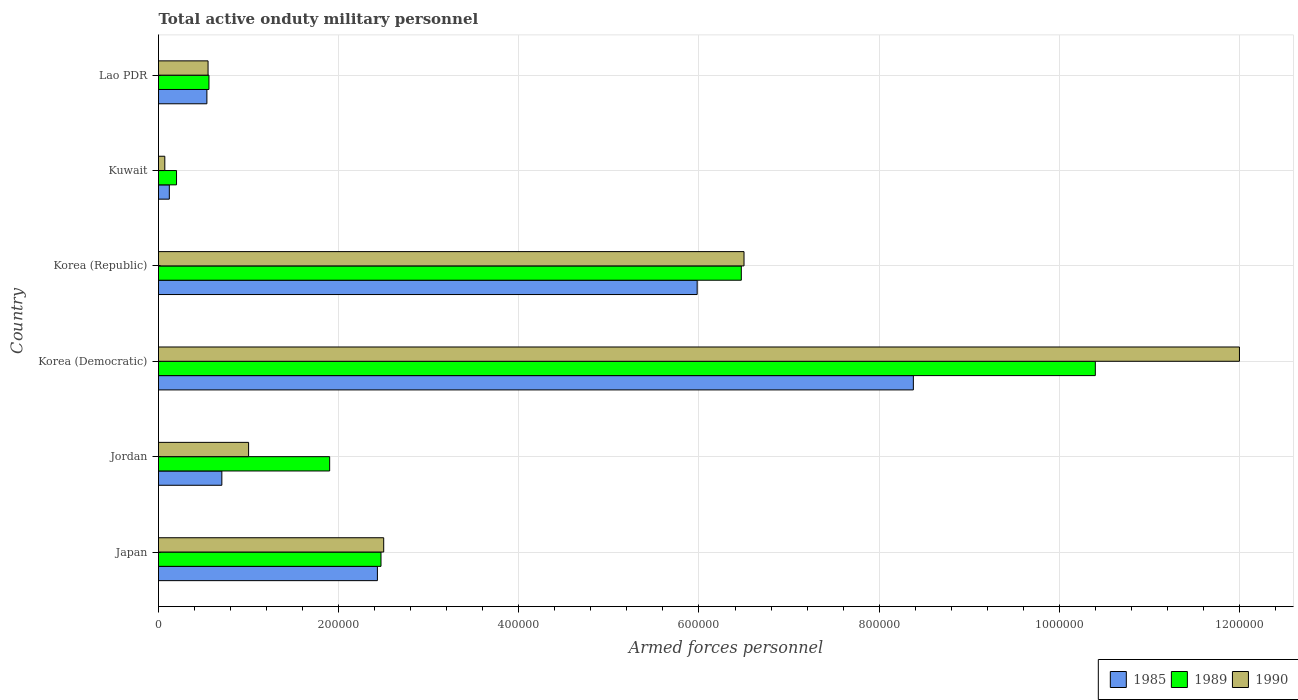How many groups of bars are there?
Offer a terse response. 6. Are the number of bars on each tick of the Y-axis equal?
Ensure brevity in your answer.  Yes. What is the label of the 3rd group of bars from the top?
Your response must be concise. Korea (Republic). In how many cases, is the number of bars for a given country not equal to the number of legend labels?
Give a very brief answer. 0. What is the number of armed forces personnel in 1990 in Korea (Republic)?
Offer a terse response. 6.50e+05. Across all countries, what is the maximum number of armed forces personnel in 1990?
Provide a short and direct response. 1.20e+06. Across all countries, what is the minimum number of armed forces personnel in 1990?
Ensure brevity in your answer.  7000. In which country was the number of armed forces personnel in 1989 maximum?
Ensure brevity in your answer.  Korea (Democratic). In which country was the number of armed forces personnel in 1989 minimum?
Keep it short and to the point. Kuwait. What is the total number of armed forces personnel in 1990 in the graph?
Provide a short and direct response. 2.26e+06. What is the difference between the number of armed forces personnel in 1985 in Korea (Democratic) and that in Kuwait?
Keep it short and to the point. 8.26e+05. What is the average number of armed forces personnel in 1990 per country?
Your answer should be compact. 3.77e+05. What is the difference between the number of armed forces personnel in 1989 and number of armed forces personnel in 1985 in Korea (Republic)?
Keep it short and to the point. 4.90e+04. What is the ratio of the number of armed forces personnel in 1989 in Japan to that in Korea (Democratic)?
Provide a short and direct response. 0.24. Is the difference between the number of armed forces personnel in 1989 in Korea (Republic) and Lao PDR greater than the difference between the number of armed forces personnel in 1985 in Korea (Republic) and Lao PDR?
Offer a very short reply. Yes. What is the difference between the highest and the second highest number of armed forces personnel in 1990?
Offer a terse response. 5.50e+05. What is the difference between the highest and the lowest number of armed forces personnel in 1989?
Provide a short and direct response. 1.02e+06. In how many countries, is the number of armed forces personnel in 1989 greater than the average number of armed forces personnel in 1989 taken over all countries?
Provide a succinct answer. 2. What does the 2nd bar from the bottom in Jordan represents?
Your answer should be compact. 1989. Is it the case that in every country, the sum of the number of armed forces personnel in 1989 and number of armed forces personnel in 1985 is greater than the number of armed forces personnel in 1990?
Your answer should be compact. Yes. Are all the bars in the graph horizontal?
Ensure brevity in your answer.  Yes. How many countries are there in the graph?
Keep it short and to the point. 6. Are the values on the major ticks of X-axis written in scientific E-notation?
Offer a terse response. No. Does the graph contain grids?
Keep it short and to the point. Yes. How are the legend labels stacked?
Offer a very short reply. Horizontal. What is the title of the graph?
Your answer should be compact. Total active onduty military personnel. Does "1969" appear as one of the legend labels in the graph?
Your response must be concise. No. What is the label or title of the X-axis?
Your response must be concise. Armed forces personnel. What is the Armed forces personnel in 1985 in Japan?
Your answer should be very brief. 2.43e+05. What is the Armed forces personnel of 1989 in Japan?
Offer a terse response. 2.47e+05. What is the Armed forces personnel of 1985 in Jordan?
Offer a very short reply. 7.03e+04. What is the Armed forces personnel of 1989 in Jordan?
Give a very brief answer. 1.90e+05. What is the Armed forces personnel of 1990 in Jordan?
Offer a terse response. 1.00e+05. What is the Armed forces personnel in 1985 in Korea (Democratic)?
Keep it short and to the point. 8.38e+05. What is the Armed forces personnel of 1989 in Korea (Democratic)?
Give a very brief answer. 1.04e+06. What is the Armed forces personnel in 1990 in Korea (Democratic)?
Provide a short and direct response. 1.20e+06. What is the Armed forces personnel in 1985 in Korea (Republic)?
Make the answer very short. 5.98e+05. What is the Armed forces personnel in 1989 in Korea (Republic)?
Provide a succinct answer. 6.47e+05. What is the Armed forces personnel of 1990 in Korea (Republic)?
Your answer should be compact. 6.50e+05. What is the Armed forces personnel of 1985 in Kuwait?
Ensure brevity in your answer.  1.20e+04. What is the Armed forces personnel in 1990 in Kuwait?
Provide a short and direct response. 7000. What is the Armed forces personnel in 1985 in Lao PDR?
Offer a terse response. 5.37e+04. What is the Armed forces personnel of 1989 in Lao PDR?
Make the answer very short. 5.60e+04. What is the Armed forces personnel of 1990 in Lao PDR?
Make the answer very short. 5.50e+04. Across all countries, what is the maximum Armed forces personnel of 1985?
Your answer should be very brief. 8.38e+05. Across all countries, what is the maximum Armed forces personnel of 1989?
Offer a terse response. 1.04e+06. Across all countries, what is the maximum Armed forces personnel in 1990?
Offer a very short reply. 1.20e+06. Across all countries, what is the minimum Armed forces personnel of 1985?
Offer a very short reply. 1.20e+04. Across all countries, what is the minimum Armed forces personnel in 1989?
Your response must be concise. 2.00e+04. Across all countries, what is the minimum Armed forces personnel of 1990?
Your answer should be compact. 7000. What is the total Armed forces personnel in 1985 in the graph?
Provide a succinct answer. 1.82e+06. What is the total Armed forces personnel in 1989 in the graph?
Your response must be concise. 2.20e+06. What is the total Armed forces personnel in 1990 in the graph?
Make the answer very short. 2.26e+06. What is the difference between the Armed forces personnel of 1985 in Japan and that in Jordan?
Ensure brevity in your answer.  1.73e+05. What is the difference between the Armed forces personnel in 1989 in Japan and that in Jordan?
Keep it short and to the point. 5.70e+04. What is the difference between the Armed forces personnel in 1985 in Japan and that in Korea (Democratic)?
Your answer should be compact. -5.95e+05. What is the difference between the Armed forces personnel of 1989 in Japan and that in Korea (Democratic)?
Provide a succinct answer. -7.93e+05. What is the difference between the Armed forces personnel in 1990 in Japan and that in Korea (Democratic)?
Keep it short and to the point. -9.50e+05. What is the difference between the Armed forces personnel of 1985 in Japan and that in Korea (Republic)?
Provide a succinct answer. -3.55e+05. What is the difference between the Armed forces personnel in 1989 in Japan and that in Korea (Republic)?
Provide a short and direct response. -4.00e+05. What is the difference between the Armed forces personnel in 1990 in Japan and that in Korea (Republic)?
Provide a succinct answer. -4.00e+05. What is the difference between the Armed forces personnel in 1985 in Japan and that in Kuwait?
Keep it short and to the point. 2.31e+05. What is the difference between the Armed forces personnel of 1989 in Japan and that in Kuwait?
Your answer should be compact. 2.27e+05. What is the difference between the Armed forces personnel of 1990 in Japan and that in Kuwait?
Your answer should be compact. 2.43e+05. What is the difference between the Armed forces personnel in 1985 in Japan and that in Lao PDR?
Your answer should be very brief. 1.89e+05. What is the difference between the Armed forces personnel in 1989 in Japan and that in Lao PDR?
Offer a very short reply. 1.91e+05. What is the difference between the Armed forces personnel in 1990 in Japan and that in Lao PDR?
Your response must be concise. 1.95e+05. What is the difference between the Armed forces personnel in 1985 in Jordan and that in Korea (Democratic)?
Give a very brief answer. -7.68e+05. What is the difference between the Armed forces personnel of 1989 in Jordan and that in Korea (Democratic)?
Provide a succinct answer. -8.50e+05. What is the difference between the Armed forces personnel of 1990 in Jordan and that in Korea (Democratic)?
Offer a terse response. -1.10e+06. What is the difference between the Armed forces personnel of 1985 in Jordan and that in Korea (Republic)?
Offer a terse response. -5.28e+05. What is the difference between the Armed forces personnel of 1989 in Jordan and that in Korea (Republic)?
Your answer should be very brief. -4.57e+05. What is the difference between the Armed forces personnel of 1990 in Jordan and that in Korea (Republic)?
Make the answer very short. -5.50e+05. What is the difference between the Armed forces personnel in 1985 in Jordan and that in Kuwait?
Provide a succinct answer. 5.83e+04. What is the difference between the Armed forces personnel of 1989 in Jordan and that in Kuwait?
Keep it short and to the point. 1.70e+05. What is the difference between the Armed forces personnel in 1990 in Jordan and that in Kuwait?
Your answer should be compact. 9.30e+04. What is the difference between the Armed forces personnel of 1985 in Jordan and that in Lao PDR?
Give a very brief answer. 1.66e+04. What is the difference between the Armed forces personnel of 1989 in Jordan and that in Lao PDR?
Offer a terse response. 1.34e+05. What is the difference between the Armed forces personnel in 1990 in Jordan and that in Lao PDR?
Offer a very short reply. 4.50e+04. What is the difference between the Armed forces personnel in 1989 in Korea (Democratic) and that in Korea (Republic)?
Your answer should be very brief. 3.93e+05. What is the difference between the Armed forces personnel in 1990 in Korea (Democratic) and that in Korea (Republic)?
Offer a very short reply. 5.50e+05. What is the difference between the Armed forces personnel of 1985 in Korea (Democratic) and that in Kuwait?
Your answer should be compact. 8.26e+05. What is the difference between the Armed forces personnel of 1989 in Korea (Democratic) and that in Kuwait?
Give a very brief answer. 1.02e+06. What is the difference between the Armed forces personnel in 1990 in Korea (Democratic) and that in Kuwait?
Keep it short and to the point. 1.19e+06. What is the difference between the Armed forces personnel of 1985 in Korea (Democratic) and that in Lao PDR?
Your answer should be compact. 7.84e+05. What is the difference between the Armed forces personnel in 1989 in Korea (Democratic) and that in Lao PDR?
Ensure brevity in your answer.  9.84e+05. What is the difference between the Armed forces personnel in 1990 in Korea (Democratic) and that in Lao PDR?
Provide a short and direct response. 1.14e+06. What is the difference between the Armed forces personnel of 1985 in Korea (Republic) and that in Kuwait?
Give a very brief answer. 5.86e+05. What is the difference between the Armed forces personnel in 1989 in Korea (Republic) and that in Kuwait?
Ensure brevity in your answer.  6.27e+05. What is the difference between the Armed forces personnel in 1990 in Korea (Republic) and that in Kuwait?
Keep it short and to the point. 6.43e+05. What is the difference between the Armed forces personnel in 1985 in Korea (Republic) and that in Lao PDR?
Provide a succinct answer. 5.44e+05. What is the difference between the Armed forces personnel in 1989 in Korea (Republic) and that in Lao PDR?
Your answer should be very brief. 5.91e+05. What is the difference between the Armed forces personnel of 1990 in Korea (Republic) and that in Lao PDR?
Offer a terse response. 5.95e+05. What is the difference between the Armed forces personnel of 1985 in Kuwait and that in Lao PDR?
Ensure brevity in your answer.  -4.17e+04. What is the difference between the Armed forces personnel in 1989 in Kuwait and that in Lao PDR?
Make the answer very short. -3.60e+04. What is the difference between the Armed forces personnel in 1990 in Kuwait and that in Lao PDR?
Your response must be concise. -4.80e+04. What is the difference between the Armed forces personnel in 1985 in Japan and the Armed forces personnel in 1989 in Jordan?
Provide a short and direct response. 5.30e+04. What is the difference between the Armed forces personnel of 1985 in Japan and the Armed forces personnel of 1990 in Jordan?
Keep it short and to the point. 1.43e+05. What is the difference between the Armed forces personnel of 1989 in Japan and the Armed forces personnel of 1990 in Jordan?
Provide a succinct answer. 1.47e+05. What is the difference between the Armed forces personnel of 1985 in Japan and the Armed forces personnel of 1989 in Korea (Democratic)?
Provide a short and direct response. -7.97e+05. What is the difference between the Armed forces personnel in 1985 in Japan and the Armed forces personnel in 1990 in Korea (Democratic)?
Provide a succinct answer. -9.57e+05. What is the difference between the Armed forces personnel of 1989 in Japan and the Armed forces personnel of 1990 in Korea (Democratic)?
Provide a short and direct response. -9.53e+05. What is the difference between the Armed forces personnel of 1985 in Japan and the Armed forces personnel of 1989 in Korea (Republic)?
Your answer should be compact. -4.04e+05. What is the difference between the Armed forces personnel of 1985 in Japan and the Armed forces personnel of 1990 in Korea (Republic)?
Your answer should be very brief. -4.07e+05. What is the difference between the Armed forces personnel in 1989 in Japan and the Armed forces personnel in 1990 in Korea (Republic)?
Provide a succinct answer. -4.03e+05. What is the difference between the Armed forces personnel in 1985 in Japan and the Armed forces personnel in 1989 in Kuwait?
Keep it short and to the point. 2.23e+05. What is the difference between the Armed forces personnel of 1985 in Japan and the Armed forces personnel of 1990 in Kuwait?
Offer a very short reply. 2.36e+05. What is the difference between the Armed forces personnel in 1989 in Japan and the Armed forces personnel in 1990 in Kuwait?
Make the answer very short. 2.40e+05. What is the difference between the Armed forces personnel in 1985 in Japan and the Armed forces personnel in 1989 in Lao PDR?
Your answer should be compact. 1.87e+05. What is the difference between the Armed forces personnel of 1985 in Japan and the Armed forces personnel of 1990 in Lao PDR?
Give a very brief answer. 1.88e+05. What is the difference between the Armed forces personnel in 1989 in Japan and the Armed forces personnel in 1990 in Lao PDR?
Keep it short and to the point. 1.92e+05. What is the difference between the Armed forces personnel in 1985 in Jordan and the Armed forces personnel in 1989 in Korea (Democratic)?
Give a very brief answer. -9.70e+05. What is the difference between the Armed forces personnel in 1985 in Jordan and the Armed forces personnel in 1990 in Korea (Democratic)?
Offer a terse response. -1.13e+06. What is the difference between the Armed forces personnel in 1989 in Jordan and the Armed forces personnel in 1990 in Korea (Democratic)?
Make the answer very short. -1.01e+06. What is the difference between the Armed forces personnel in 1985 in Jordan and the Armed forces personnel in 1989 in Korea (Republic)?
Provide a short and direct response. -5.77e+05. What is the difference between the Armed forces personnel of 1985 in Jordan and the Armed forces personnel of 1990 in Korea (Republic)?
Make the answer very short. -5.80e+05. What is the difference between the Armed forces personnel in 1989 in Jordan and the Armed forces personnel in 1990 in Korea (Republic)?
Your answer should be very brief. -4.60e+05. What is the difference between the Armed forces personnel in 1985 in Jordan and the Armed forces personnel in 1989 in Kuwait?
Keep it short and to the point. 5.03e+04. What is the difference between the Armed forces personnel of 1985 in Jordan and the Armed forces personnel of 1990 in Kuwait?
Your answer should be compact. 6.33e+04. What is the difference between the Armed forces personnel in 1989 in Jordan and the Armed forces personnel in 1990 in Kuwait?
Provide a short and direct response. 1.83e+05. What is the difference between the Armed forces personnel of 1985 in Jordan and the Armed forces personnel of 1989 in Lao PDR?
Your answer should be very brief. 1.43e+04. What is the difference between the Armed forces personnel of 1985 in Jordan and the Armed forces personnel of 1990 in Lao PDR?
Offer a terse response. 1.53e+04. What is the difference between the Armed forces personnel of 1989 in Jordan and the Armed forces personnel of 1990 in Lao PDR?
Offer a terse response. 1.35e+05. What is the difference between the Armed forces personnel in 1985 in Korea (Democratic) and the Armed forces personnel in 1989 in Korea (Republic)?
Offer a terse response. 1.91e+05. What is the difference between the Armed forces personnel of 1985 in Korea (Democratic) and the Armed forces personnel of 1990 in Korea (Republic)?
Keep it short and to the point. 1.88e+05. What is the difference between the Armed forces personnel of 1989 in Korea (Democratic) and the Armed forces personnel of 1990 in Korea (Republic)?
Your answer should be compact. 3.90e+05. What is the difference between the Armed forces personnel of 1985 in Korea (Democratic) and the Armed forces personnel of 1989 in Kuwait?
Provide a succinct answer. 8.18e+05. What is the difference between the Armed forces personnel of 1985 in Korea (Democratic) and the Armed forces personnel of 1990 in Kuwait?
Your answer should be very brief. 8.31e+05. What is the difference between the Armed forces personnel of 1989 in Korea (Democratic) and the Armed forces personnel of 1990 in Kuwait?
Provide a succinct answer. 1.03e+06. What is the difference between the Armed forces personnel in 1985 in Korea (Democratic) and the Armed forces personnel in 1989 in Lao PDR?
Your answer should be very brief. 7.82e+05. What is the difference between the Armed forces personnel of 1985 in Korea (Democratic) and the Armed forces personnel of 1990 in Lao PDR?
Keep it short and to the point. 7.83e+05. What is the difference between the Armed forces personnel in 1989 in Korea (Democratic) and the Armed forces personnel in 1990 in Lao PDR?
Make the answer very short. 9.85e+05. What is the difference between the Armed forces personnel in 1985 in Korea (Republic) and the Armed forces personnel in 1989 in Kuwait?
Your answer should be compact. 5.78e+05. What is the difference between the Armed forces personnel in 1985 in Korea (Republic) and the Armed forces personnel in 1990 in Kuwait?
Ensure brevity in your answer.  5.91e+05. What is the difference between the Armed forces personnel of 1989 in Korea (Republic) and the Armed forces personnel of 1990 in Kuwait?
Provide a succinct answer. 6.40e+05. What is the difference between the Armed forces personnel in 1985 in Korea (Republic) and the Armed forces personnel in 1989 in Lao PDR?
Give a very brief answer. 5.42e+05. What is the difference between the Armed forces personnel in 1985 in Korea (Republic) and the Armed forces personnel in 1990 in Lao PDR?
Your response must be concise. 5.43e+05. What is the difference between the Armed forces personnel of 1989 in Korea (Republic) and the Armed forces personnel of 1990 in Lao PDR?
Offer a terse response. 5.92e+05. What is the difference between the Armed forces personnel in 1985 in Kuwait and the Armed forces personnel in 1989 in Lao PDR?
Ensure brevity in your answer.  -4.40e+04. What is the difference between the Armed forces personnel of 1985 in Kuwait and the Armed forces personnel of 1990 in Lao PDR?
Make the answer very short. -4.30e+04. What is the difference between the Armed forces personnel in 1989 in Kuwait and the Armed forces personnel in 1990 in Lao PDR?
Make the answer very short. -3.50e+04. What is the average Armed forces personnel of 1985 per country?
Your answer should be very brief. 3.02e+05. What is the average Armed forces personnel in 1989 per country?
Offer a terse response. 3.67e+05. What is the average Armed forces personnel of 1990 per country?
Offer a very short reply. 3.77e+05. What is the difference between the Armed forces personnel of 1985 and Armed forces personnel of 1989 in Japan?
Offer a very short reply. -4000. What is the difference between the Armed forces personnel in 1985 and Armed forces personnel in 1990 in Japan?
Keep it short and to the point. -7000. What is the difference between the Armed forces personnel of 1989 and Armed forces personnel of 1990 in Japan?
Provide a succinct answer. -3000. What is the difference between the Armed forces personnel of 1985 and Armed forces personnel of 1989 in Jordan?
Give a very brief answer. -1.20e+05. What is the difference between the Armed forces personnel in 1985 and Armed forces personnel in 1990 in Jordan?
Provide a short and direct response. -2.97e+04. What is the difference between the Armed forces personnel in 1985 and Armed forces personnel in 1989 in Korea (Democratic)?
Offer a terse response. -2.02e+05. What is the difference between the Armed forces personnel in 1985 and Armed forces personnel in 1990 in Korea (Democratic)?
Your response must be concise. -3.62e+05. What is the difference between the Armed forces personnel of 1989 and Armed forces personnel of 1990 in Korea (Democratic)?
Provide a succinct answer. -1.60e+05. What is the difference between the Armed forces personnel in 1985 and Armed forces personnel in 1989 in Korea (Republic)?
Your response must be concise. -4.90e+04. What is the difference between the Armed forces personnel of 1985 and Armed forces personnel of 1990 in Korea (Republic)?
Offer a terse response. -5.20e+04. What is the difference between the Armed forces personnel of 1989 and Armed forces personnel of 1990 in Korea (Republic)?
Provide a succinct answer. -3000. What is the difference between the Armed forces personnel of 1985 and Armed forces personnel of 1989 in Kuwait?
Make the answer very short. -8000. What is the difference between the Armed forces personnel of 1989 and Armed forces personnel of 1990 in Kuwait?
Provide a succinct answer. 1.30e+04. What is the difference between the Armed forces personnel in 1985 and Armed forces personnel in 1989 in Lao PDR?
Make the answer very short. -2300. What is the difference between the Armed forces personnel of 1985 and Armed forces personnel of 1990 in Lao PDR?
Your response must be concise. -1300. What is the ratio of the Armed forces personnel of 1985 in Japan to that in Jordan?
Your response must be concise. 3.46. What is the ratio of the Armed forces personnel in 1989 in Japan to that in Jordan?
Provide a short and direct response. 1.3. What is the ratio of the Armed forces personnel in 1990 in Japan to that in Jordan?
Your response must be concise. 2.5. What is the ratio of the Armed forces personnel in 1985 in Japan to that in Korea (Democratic)?
Provide a short and direct response. 0.29. What is the ratio of the Armed forces personnel in 1989 in Japan to that in Korea (Democratic)?
Keep it short and to the point. 0.24. What is the ratio of the Armed forces personnel of 1990 in Japan to that in Korea (Democratic)?
Keep it short and to the point. 0.21. What is the ratio of the Armed forces personnel in 1985 in Japan to that in Korea (Republic)?
Make the answer very short. 0.41. What is the ratio of the Armed forces personnel of 1989 in Japan to that in Korea (Republic)?
Offer a terse response. 0.38. What is the ratio of the Armed forces personnel of 1990 in Japan to that in Korea (Republic)?
Ensure brevity in your answer.  0.38. What is the ratio of the Armed forces personnel of 1985 in Japan to that in Kuwait?
Give a very brief answer. 20.25. What is the ratio of the Armed forces personnel of 1989 in Japan to that in Kuwait?
Your answer should be very brief. 12.35. What is the ratio of the Armed forces personnel of 1990 in Japan to that in Kuwait?
Your response must be concise. 35.71. What is the ratio of the Armed forces personnel of 1985 in Japan to that in Lao PDR?
Provide a succinct answer. 4.53. What is the ratio of the Armed forces personnel of 1989 in Japan to that in Lao PDR?
Make the answer very short. 4.41. What is the ratio of the Armed forces personnel in 1990 in Japan to that in Lao PDR?
Your response must be concise. 4.55. What is the ratio of the Armed forces personnel in 1985 in Jordan to that in Korea (Democratic)?
Keep it short and to the point. 0.08. What is the ratio of the Armed forces personnel in 1989 in Jordan to that in Korea (Democratic)?
Provide a succinct answer. 0.18. What is the ratio of the Armed forces personnel in 1990 in Jordan to that in Korea (Democratic)?
Your response must be concise. 0.08. What is the ratio of the Armed forces personnel of 1985 in Jordan to that in Korea (Republic)?
Your answer should be very brief. 0.12. What is the ratio of the Armed forces personnel in 1989 in Jordan to that in Korea (Republic)?
Give a very brief answer. 0.29. What is the ratio of the Armed forces personnel in 1990 in Jordan to that in Korea (Republic)?
Your response must be concise. 0.15. What is the ratio of the Armed forces personnel in 1985 in Jordan to that in Kuwait?
Ensure brevity in your answer.  5.86. What is the ratio of the Armed forces personnel in 1989 in Jordan to that in Kuwait?
Keep it short and to the point. 9.5. What is the ratio of the Armed forces personnel in 1990 in Jordan to that in Kuwait?
Your response must be concise. 14.29. What is the ratio of the Armed forces personnel in 1985 in Jordan to that in Lao PDR?
Provide a succinct answer. 1.31. What is the ratio of the Armed forces personnel of 1989 in Jordan to that in Lao PDR?
Offer a very short reply. 3.39. What is the ratio of the Armed forces personnel of 1990 in Jordan to that in Lao PDR?
Your response must be concise. 1.82. What is the ratio of the Armed forces personnel of 1985 in Korea (Democratic) to that in Korea (Republic)?
Your answer should be very brief. 1.4. What is the ratio of the Armed forces personnel in 1989 in Korea (Democratic) to that in Korea (Republic)?
Offer a very short reply. 1.61. What is the ratio of the Armed forces personnel of 1990 in Korea (Democratic) to that in Korea (Republic)?
Provide a short and direct response. 1.85. What is the ratio of the Armed forces personnel of 1985 in Korea (Democratic) to that in Kuwait?
Ensure brevity in your answer.  69.83. What is the ratio of the Armed forces personnel in 1989 in Korea (Democratic) to that in Kuwait?
Your response must be concise. 52. What is the ratio of the Armed forces personnel in 1990 in Korea (Democratic) to that in Kuwait?
Offer a very short reply. 171.43. What is the ratio of the Armed forces personnel of 1985 in Korea (Democratic) to that in Lao PDR?
Offer a very short reply. 15.61. What is the ratio of the Armed forces personnel of 1989 in Korea (Democratic) to that in Lao PDR?
Your answer should be compact. 18.57. What is the ratio of the Armed forces personnel in 1990 in Korea (Democratic) to that in Lao PDR?
Provide a succinct answer. 21.82. What is the ratio of the Armed forces personnel of 1985 in Korea (Republic) to that in Kuwait?
Provide a short and direct response. 49.83. What is the ratio of the Armed forces personnel in 1989 in Korea (Republic) to that in Kuwait?
Keep it short and to the point. 32.35. What is the ratio of the Armed forces personnel of 1990 in Korea (Republic) to that in Kuwait?
Give a very brief answer. 92.86. What is the ratio of the Armed forces personnel in 1985 in Korea (Republic) to that in Lao PDR?
Make the answer very short. 11.14. What is the ratio of the Armed forces personnel of 1989 in Korea (Republic) to that in Lao PDR?
Your response must be concise. 11.55. What is the ratio of the Armed forces personnel of 1990 in Korea (Republic) to that in Lao PDR?
Ensure brevity in your answer.  11.82. What is the ratio of the Armed forces personnel in 1985 in Kuwait to that in Lao PDR?
Offer a very short reply. 0.22. What is the ratio of the Armed forces personnel in 1989 in Kuwait to that in Lao PDR?
Your response must be concise. 0.36. What is the ratio of the Armed forces personnel of 1990 in Kuwait to that in Lao PDR?
Your response must be concise. 0.13. What is the difference between the highest and the second highest Armed forces personnel in 1989?
Ensure brevity in your answer.  3.93e+05. What is the difference between the highest and the lowest Armed forces personnel in 1985?
Ensure brevity in your answer.  8.26e+05. What is the difference between the highest and the lowest Armed forces personnel in 1989?
Your response must be concise. 1.02e+06. What is the difference between the highest and the lowest Armed forces personnel of 1990?
Provide a succinct answer. 1.19e+06. 